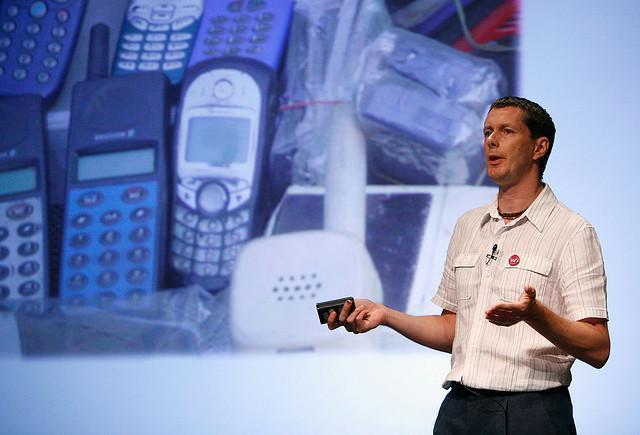How many cell phones are visible?
Give a very brief answer. 7. 